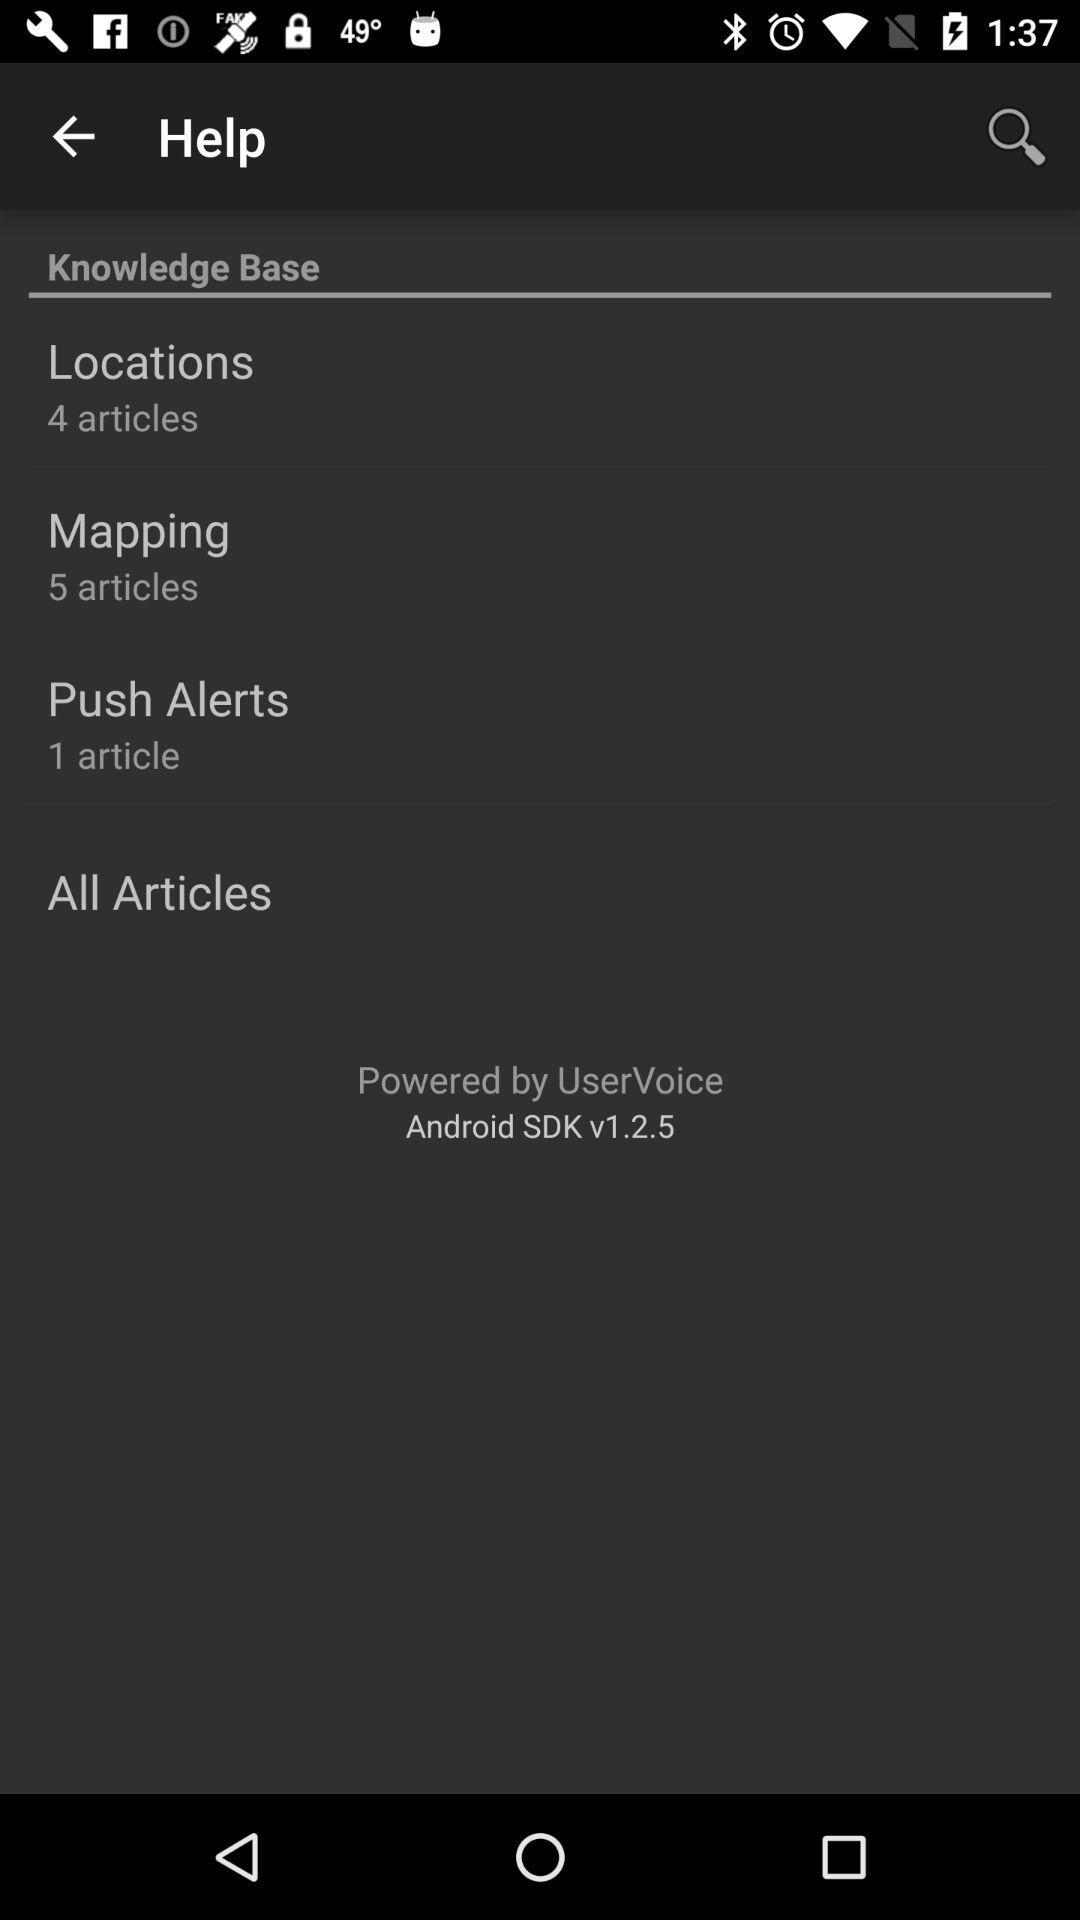What is the number of articles in the location category? The number of articles in the location category is 4. 